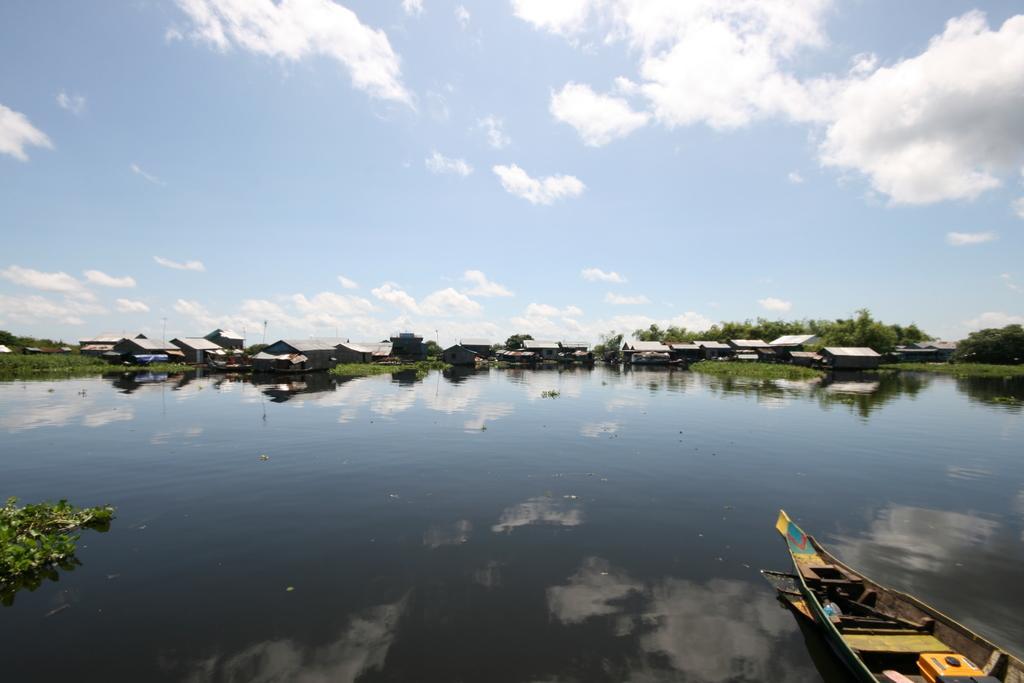Can you describe this image briefly? On the right side, there is a boat on the water. On the left side, there are plants. In the background, there are houses and trees on the ground. And there are clouds in the blue sky. 